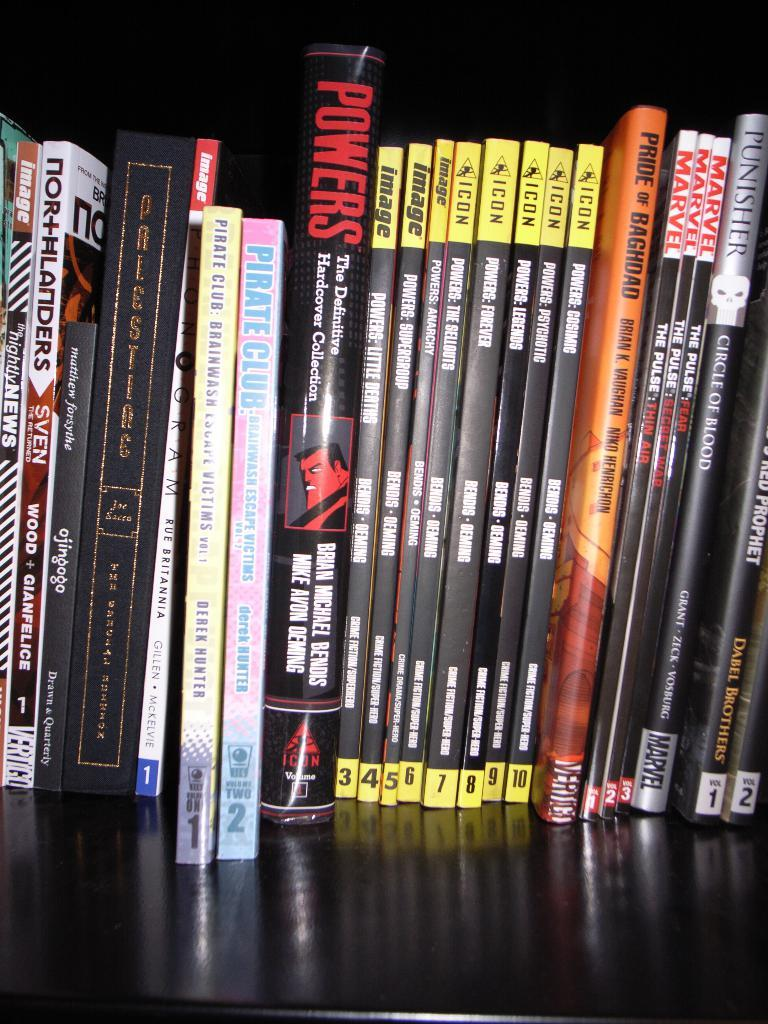<image>
Summarize the visual content of the image. Several books lined up on a shelf with some named Powers or Marvel. 